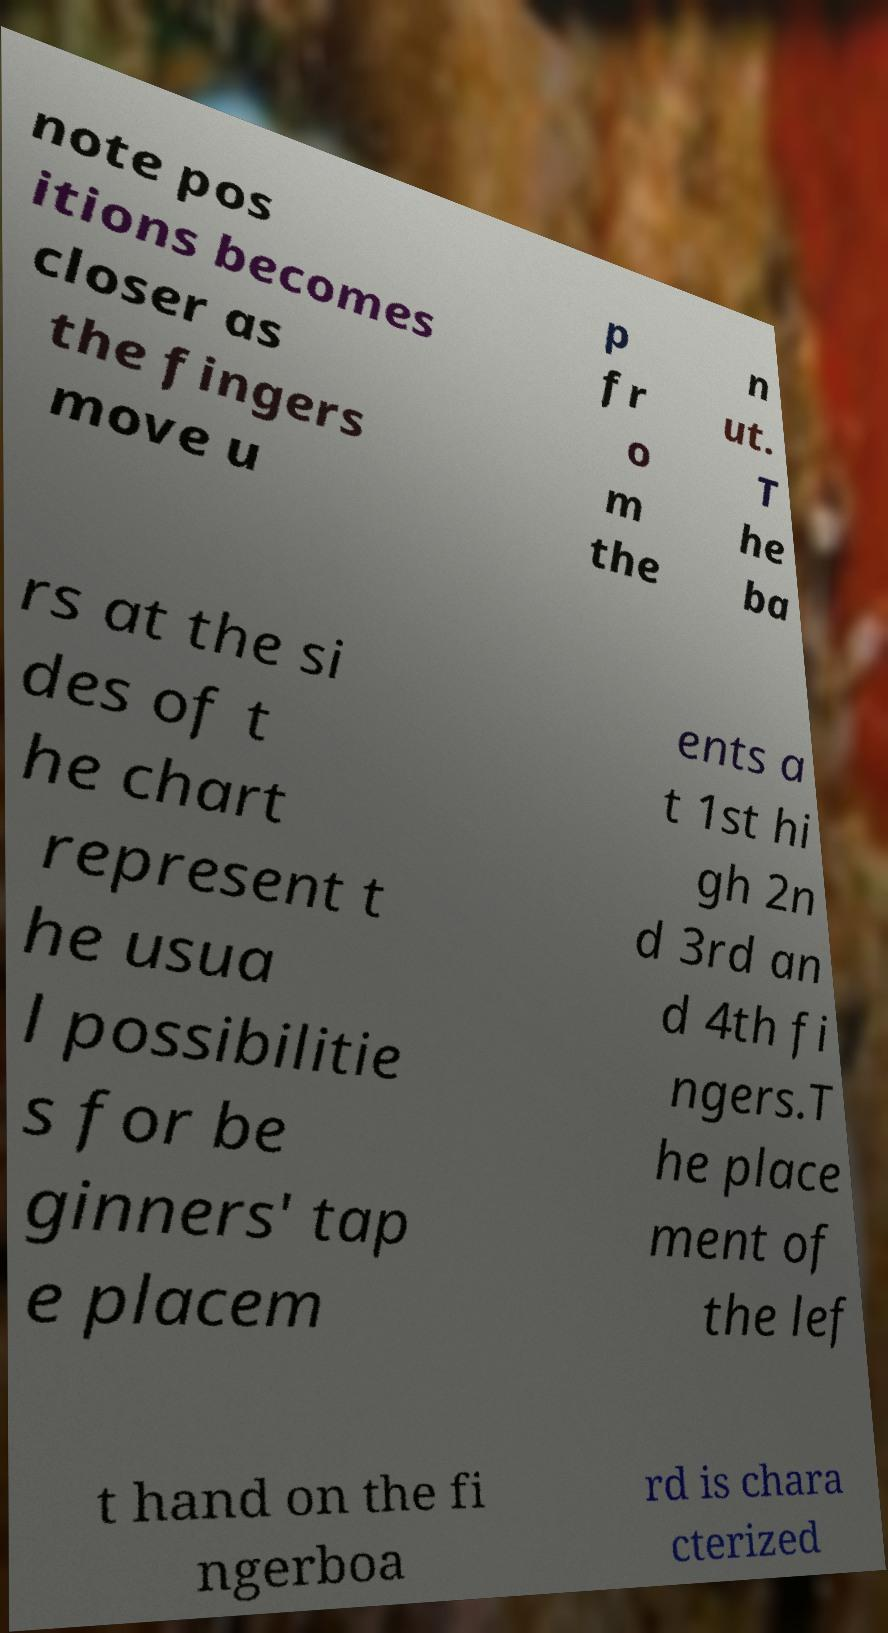I need the written content from this picture converted into text. Can you do that? note pos itions becomes closer as the fingers move u p fr o m the n ut. T he ba rs at the si des of t he chart represent t he usua l possibilitie s for be ginners' tap e placem ents a t 1st hi gh 2n d 3rd an d 4th fi ngers.T he place ment of the lef t hand on the fi ngerboa rd is chara cterized 